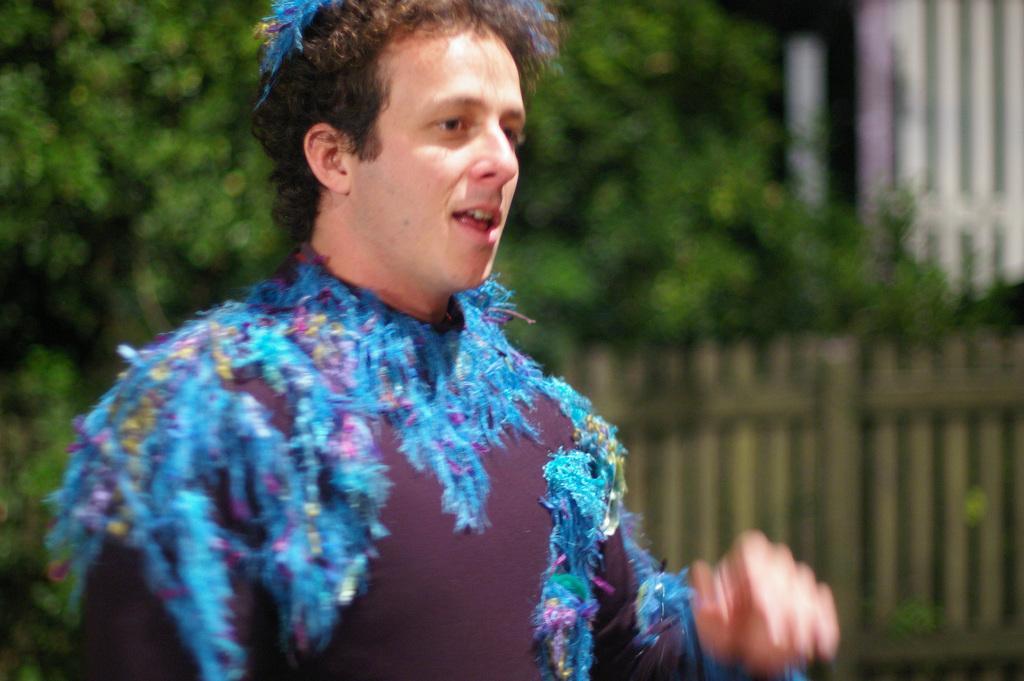Could you give a brief overview of what you see in this image? In this image in the front there is a person standing. In the background there are trees and there is a wooden fence. 